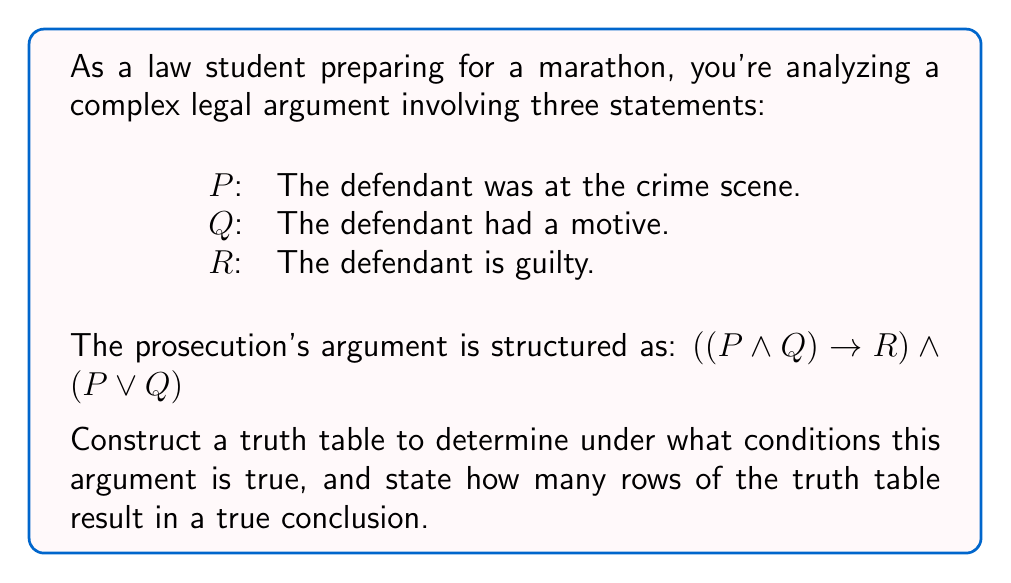What is the answer to this math problem? Let's approach this step-by-step:

1) First, we need to construct a truth table with columns for P, Q, R, and the compound statements.

2) The truth table will have $2^3 = 8$ rows, as there are three variables.

3) Let's break down the compound statement:
   $((P \land Q) \rightarrow R) \land (P \lor Q)$

4) We'll evaluate each part separately:
   a) $(P \land Q)$
   b) $(P \land Q) \rightarrow R$
   c) $(P \lor Q)$
   d) The entire statement

5) Here's the truth table:

   $$
   \begin{array}{|c|c|c|c|c|c|c|}
   \hline
   P & Q & R & P \land Q & (P \land Q) \rightarrow R & P \lor Q & \text{Result} \\
   \hline
   T & T & T & T & T & T & T \\
   T & T & F & T & F & T & F \\
   T & F & T & F & T & T & T \\
   T & F & F & F & T & T & T \\
   F & T & T & F & T & T & T \\
   F & T & F & F & T & T & T \\
   F & F & T & F & T & F & F \\
   F & F & F & F & T & F & F \\
   \hline
   \end{array}
   $$

6) The result column shows when the entire statement is true.

7) Counting the true results, we see that the argument is true in 4 out of 8 cases.

This analysis shows that the prosecution's argument structure is valid in half of the possible scenarios, which might be considered a relatively weak argument in a legal context where "beyond reasonable doubt" is often the standard.
Answer: 4 rows 